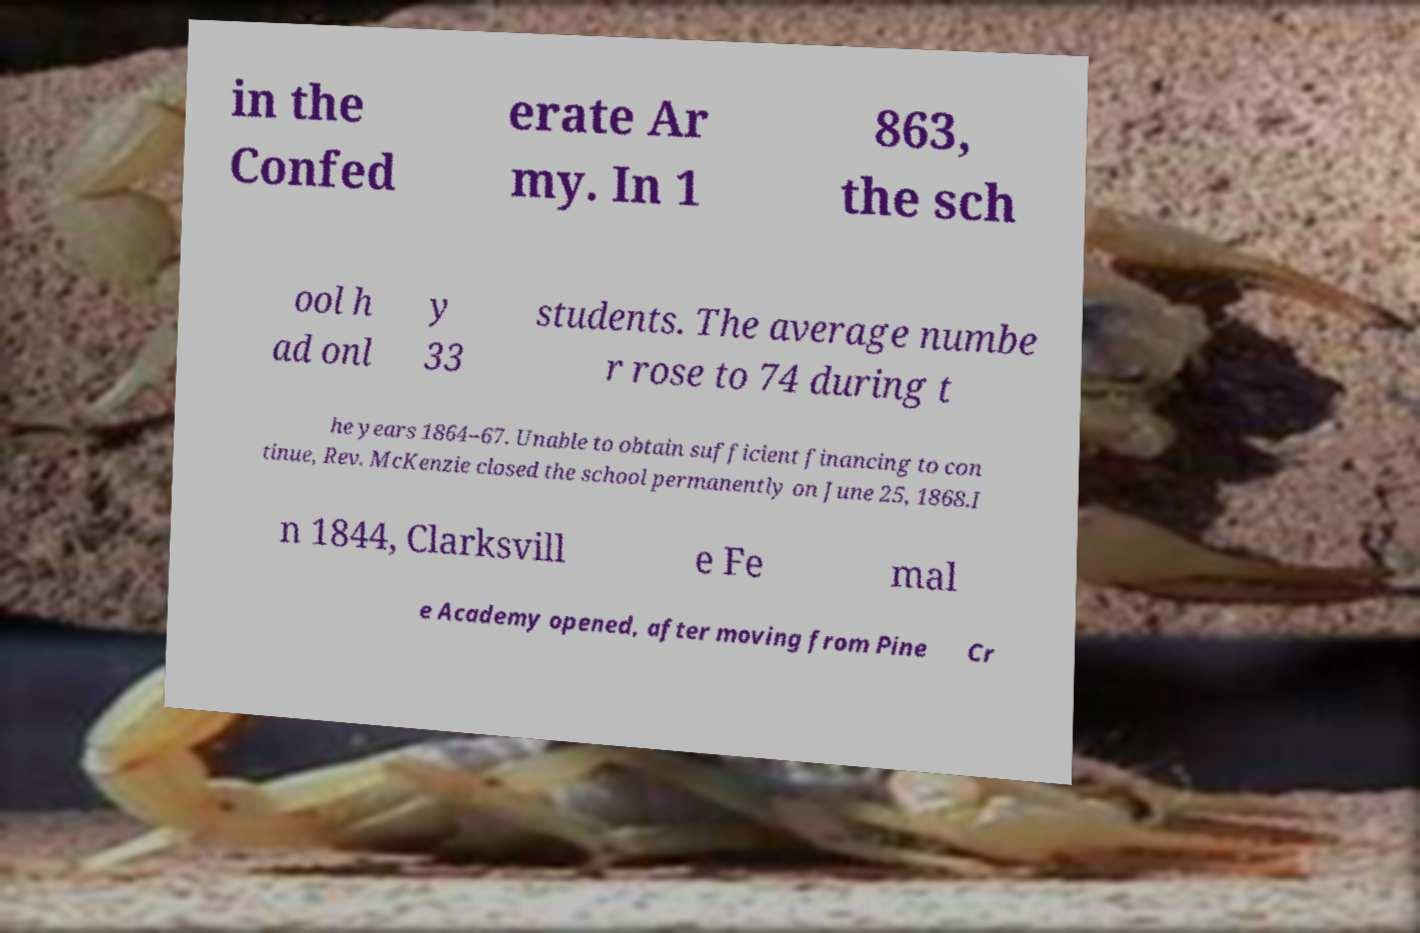For documentation purposes, I need the text within this image transcribed. Could you provide that? in the Confed erate Ar my. In 1 863, the sch ool h ad onl y 33 students. The average numbe r rose to 74 during t he years 1864–67. Unable to obtain sufficient financing to con tinue, Rev. McKenzie closed the school permanently on June 25, 1868.I n 1844, Clarksvill e Fe mal e Academy opened, after moving from Pine Cr 